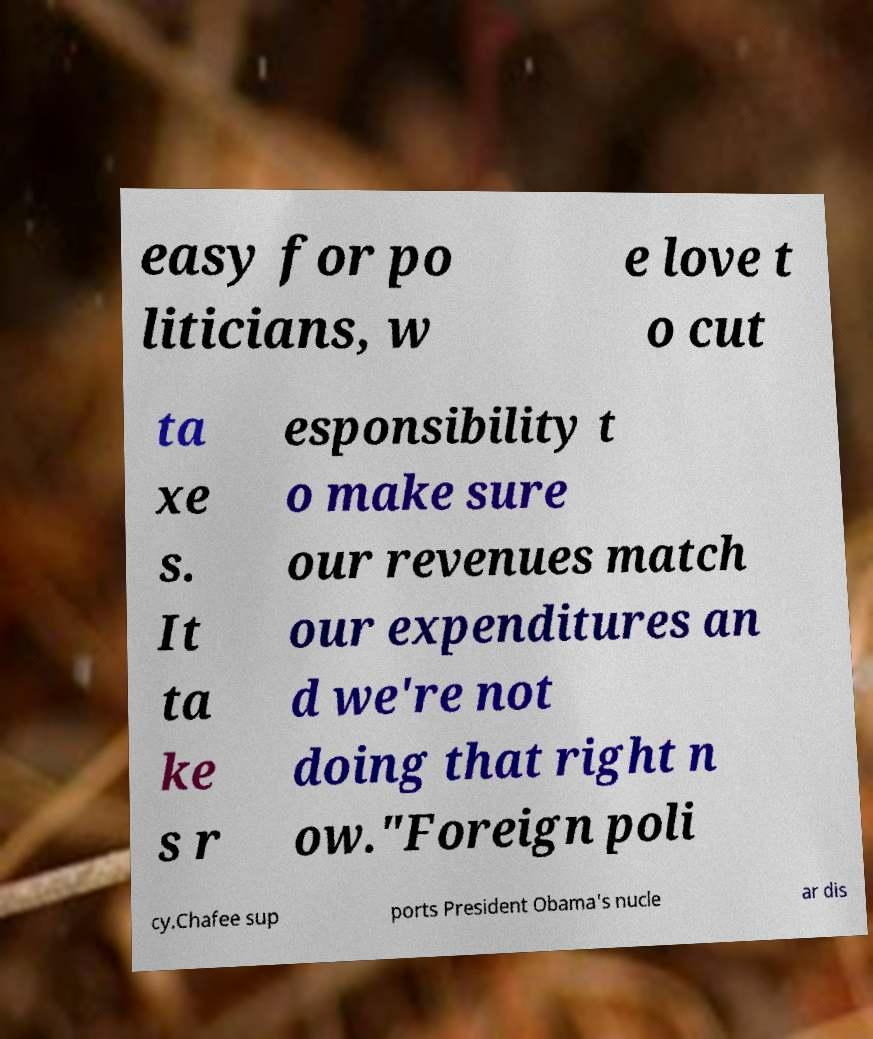There's text embedded in this image that I need extracted. Can you transcribe it verbatim? easy for po liticians, w e love t o cut ta xe s. It ta ke s r esponsibility t o make sure our revenues match our expenditures an d we're not doing that right n ow."Foreign poli cy.Chafee sup ports President Obama's nucle ar dis 